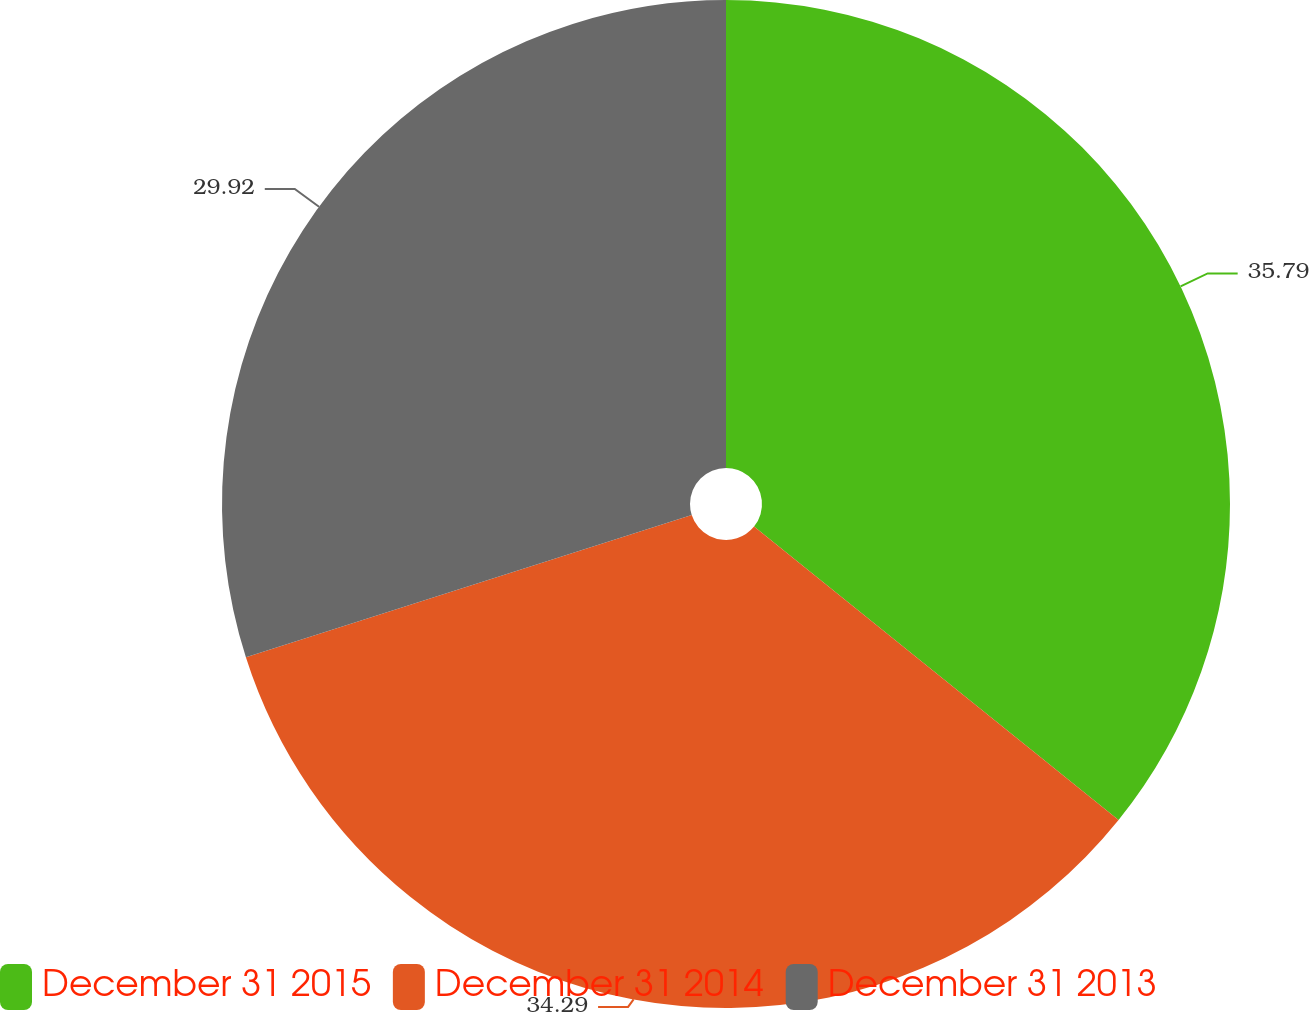Convert chart to OTSL. <chart><loc_0><loc_0><loc_500><loc_500><pie_chart><fcel>December 31 2015<fcel>December 31 2014<fcel>December 31 2013<nl><fcel>35.79%<fcel>34.29%<fcel>29.92%<nl></chart> 